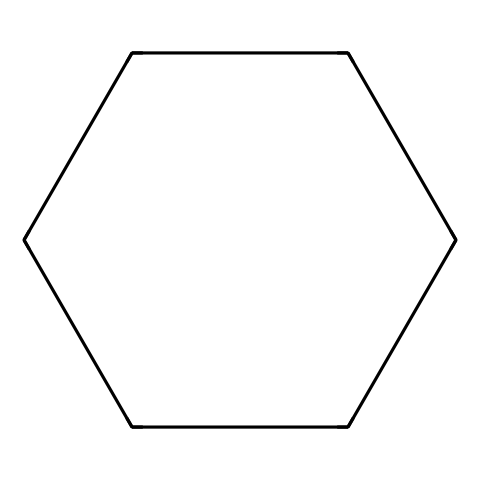What is the name of this chemical? The SMILES representation "C1CCCCC1" corresponds to cyclohexane. The structure indicates a six-membered carbon ring without any unsaturation, which is characteristic of cycloalkanes.
Answer: cyclohexane How many carbon atoms are in this structure? Analyzing the structure from the SMILES, "C1CCCCC1" indicates that there are six carbon atoms in total, represented by the six "C" characters in the ring.
Answer: six How many hydrogen atoms are bonded to the ring in cyclohexane? Each carbon in cyclohexane typically bonds to two hydrogen atoms due to its tetravalent nature (four bonds). With six carbons, the total number of hydrogen atoms is calculated as 12, following the formula CnH2n for cycloalkanes with n being the number of carbon atoms.
Answer: twelve What type of bonding is present between the carbon atoms? The bonds between the carbon atoms in cyclohexane are single covalent bonds, as there are no double or triple bonds indicated in the SMILES structure. Each carbon shares a pair of electrons with its neighboring carbons.
Answer: single covalent What is the general formula for cycloalkanes? Cycloalkanes follow the general molecular formula CnH2n. This fits with the structure of cyclohexane (with n = 6), which conforms to this rule giving it a formula of C6H12.
Answer: CnH2n Can cyclohexane exist in different conformations? Yes, cyclohexane can exist in multiple conformations, primarily chair and boat forms. The chair conformation is typically favored due to its lower energy and minimized steric strain compared to the boat form.
Answer: yes 